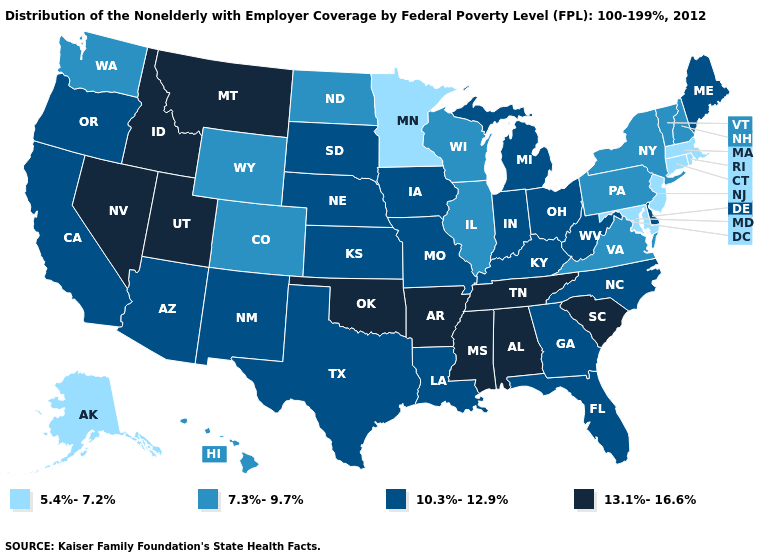Name the states that have a value in the range 7.3%-9.7%?
Be succinct. Colorado, Hawaii, Illinois, New Hampshire, New York, North Dakota, Pennsylvania, Vermont, Virginia, Washington, Wisconsin, Wyoming. Name the states that have a value in the range 13.1%-16.6%?
Keep it brief. Alabama, Arkansas, Idaho, Mississippi, Montana, Nevada, Oklahoma, South Carolina, Tennessee, Utah. Is the legend a continuous bar?
Keep it brief. No. Which states have the lowest value in the USA?
Give a very brief answer. Alaska, Connecticut, Maryland, Massachusetts, Minnesota, New Jersey, Rhode Island. Does Connecticut have the same value as Maryland?
Quick response, please. Yes. What is the lowest value in the MidWest?
Quick response, please. 5.4%-7.2%. What is the value of Montana?
Keep it brief. 13.1%-16.6%. What is the lowest value in states that border New Jersey?
Be succinct. 7.3%-9.7%. Does Massachusetts have the lowest value in the USA?
Short answer required. Yes. Name the states that have a value in the range 5.4%-7.2%?
Give a very brief answer. Alaska, Connecticut, Maryland, Massachusetts, Minnesota, New Jersey, Rhode Island. Among the states that border Connecticut , does New York have the lowest value?
Give a very brief answer. No. Does the first symbol in the legend represent the smallest category?
Quick response, please. Yes. What is the lowest value in states that border Wyoming?
Answer briefly. 7.3%-9.7%. How many symbols are there in the legend?
Answer briefly. 4. What is the highest value in states that border Georgia?
Quick response, please. 13.1%-16.6%. 